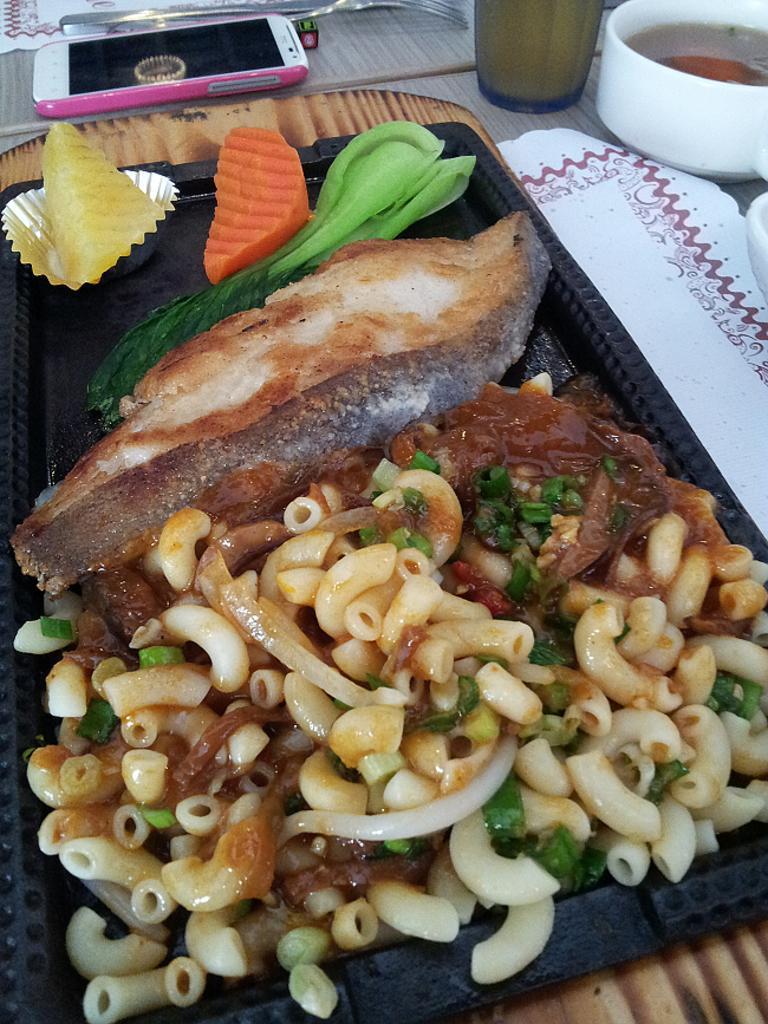Can you describe this image briefly? In this image we can see the table, on the table, we can see a tray with some food items and there is a bowl, spoon, cell phone, glass, drink and a few objects. 